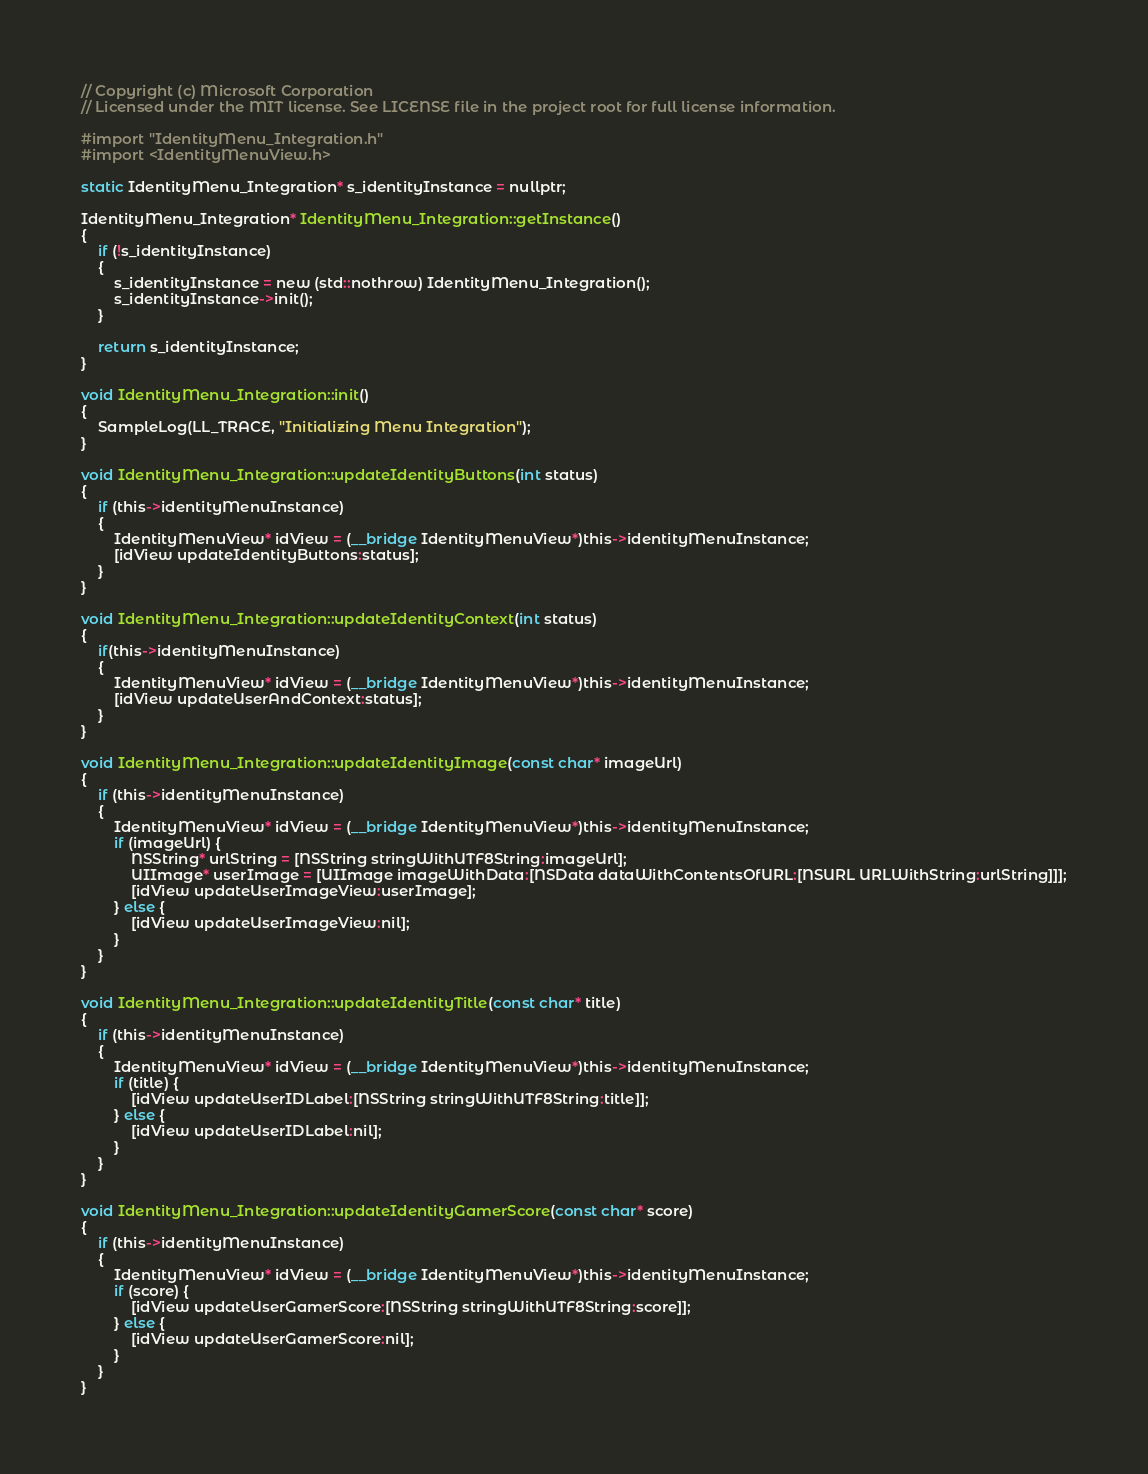<code> <loc_0><loc_0><loc_500><loc_500><_ObjectiveC_>// Copyright (c) Microsoft Corporation
// Licensed under the MIT license. See LICENSE file in the project root for full license information.

#import "IdentityMenu_Integration.h"
#import <IdentityMenuView.h>

static IdentityMenu_Integration* s_identityInstance = nullptr;

IdentityMenu_Integration* IdentityMenu_Integration::getInstance()
{
    if (!s_identityInstance)
    {
        s_identityInstance = new (std::nothrow) IdentityMenu_Integration();
        s_identityInstance->init();
    }
    
    return s_identityInstance;
}

void IdentityMenu_Integration::init()
{
    SampleLog(LL_TRACE, "Initializing Menu Integration");
}

void IdentityMenu_Integration::updateIdentityButtons(int status)
{
    if (this->identityMenuInstance)
    {
        IdentityMenuView* idView = (__bridge IdentityMenuView*)this->identityMenuInstance;
        [idView updateIdentityButtons:status];
    }
}

void IdentityMenu_Integration::updateIdentityContext(int status)
{
    if(this->identityMenuInstance)
    {
        IdentityMenuView* idView = (__bridge IdentityMenuView*)this->identityMenuInstance;
        [idView updateUserAndContext:status];
    }
}

void IdentityMenu_Integration::updateIdentityImage(const char* imageUrl)
{
    if (this->identityMenuInstance)
    {
        IdentityMenuView* idView = (__bridge IdentityMenuView*)this->identityMenuInstance;
        if (imageUrl) {
            NSString* urlString = [NSString stringWithUTF8String:imageUrl];
            UIImage* userImage = [UIImage imageWithData:[NSData dataWithContentsOfURL:[NSURL URLWithString:urlString]]];
            [idView updateUserImageView:userImage];
        } else {
            [idView updateUserImageView:nil];
        }
    }
}

void IdentityMenu_Integration::updateIdentityTitle(const char* title)
{
    if (this->identityMenuInstance)
    {
        IdentityMenuView* idView = (__bridge IdentityMenuView*)this->identityMenuInstance;
        if (title) {
            [idView updateUserIDLabel:[NSString stringWithUTF8String:title]];
        } else {
            [idView updateUserIDLabel:nil];
        }
    }
}

void IdentityMenu_Integration::updateIdentityGamerScore(const char* score)
{
    if (this->identityMenuInstance)
    {
        IdentityMenuView* idView = (__bridge IdentityMenuView*)this->identityMenuInstance;
        if (score) {
            [idView updateUserGamerScore:[NSString stringWithUTF8String:score]];
        } else {
            [idView updateUserGamerScore:nil];
        }
    }
}
</code> 